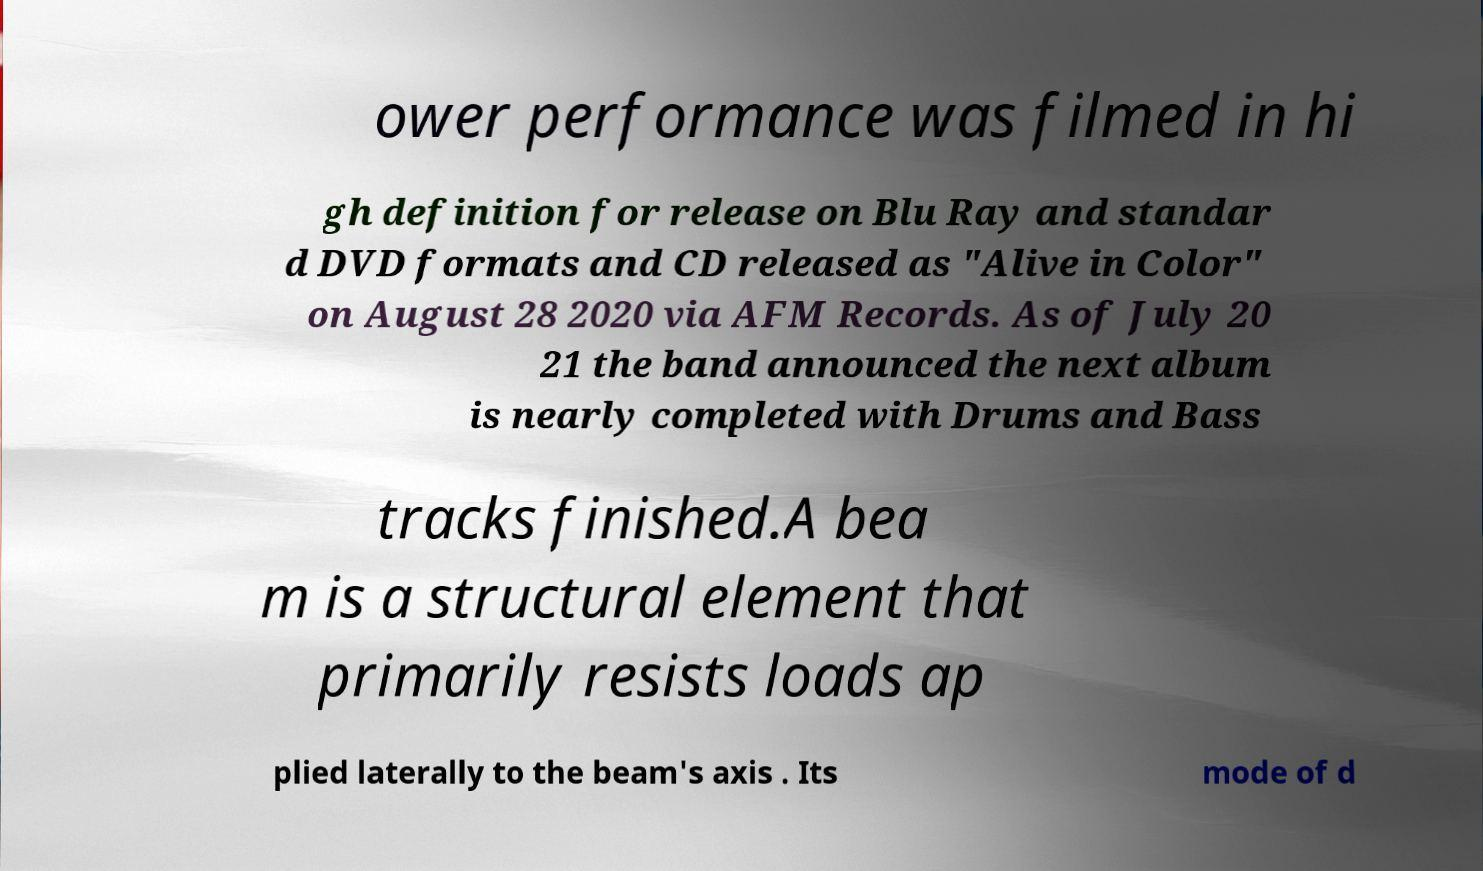Please identify and transcribe the text found in this image. ower performance was filmed in hi gh definition for release on Blu Ray and standar d DVD formats and CD released as "Alive in Color" on August 28 2020 via AFM Records. As of July 20 21 the band announced the next album is nearly completed with Drums and Bass tracks finished.A bea m is a structural element that primarily resists loads ap plied laterally to the beam's axis . Its mode of d 